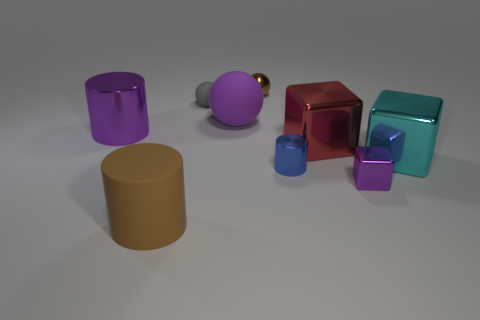How many matte objects are the same color as the shiny ball?
Provide a short and direct response. 1. How many large purple spheres are left of the small purple metallic block?
Provide a short and direct response. 1. There is a cylinder that is right of the brown matte cylinder; is its size the same as the purple metal cube?
Give a very brief answer. Yes. What color is the other large thing that is the same shape as the red object?
Give a very brief answer. Cyan. What is the shape of the rubber object that is in front of the red block?
Provide a short and direct response. Cylinder. What number of big purple things are the same shape as the gray object?
Keep it short and to the point. 1. Is the color of the large matte object behind the tiny purple metal cube the same as the ball on the right side of the purple rubber sphere?
Make the answer very short. No. How many objects are either small yellow objects or large brown objects?
Offer a very short reply. 1. How many tiny blue cylinders have the same material as the large cyan block?
Your answer should be compact. 1. Are there fewer large metal cylinders than big gray rubber cubes?
Make the answer very short. No. 